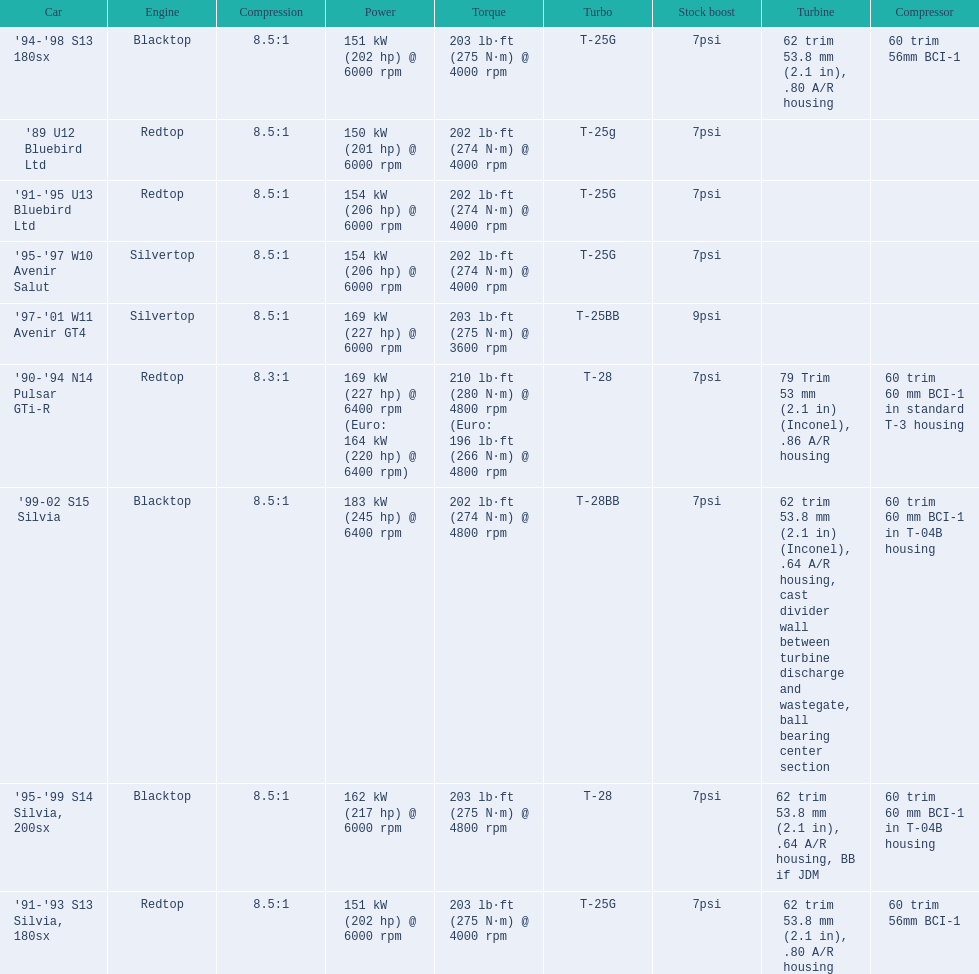Which cars featured blacktop engines? '94-'98 S13 180sx, '95-'99 S14 Silvia, 200sx, '99-02 S15 Silvia. Which of these had t-04b compressor housings? '95-'99 S14 Silvia, 200sx, '99-02 S15 Silvia. Which one of these has the highest horsepower? '99-02 S15 Silvia. 